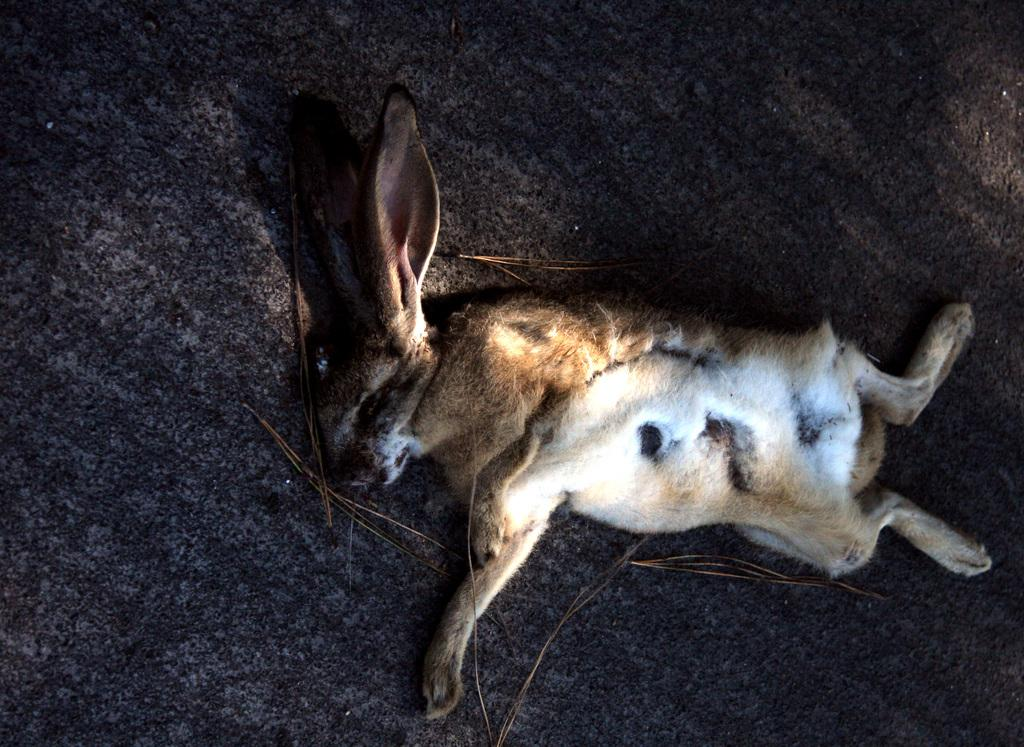What type of creature is in the image? There is an animal in the image. What is the animal doing in the image? The animal is laying on the ground. Where is the animal located in the image? The animal is in the center of the image. How many goldfish are swimming in the image? There are no goldfish present in the image; it features an animal laying on the ground. What type of car is visible in the image? There are no cars present in the image. 